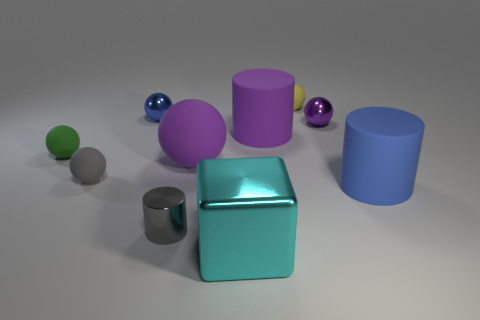There is a big thing that is left of the large cyan thing that is in front of the purple matte object in front of the tiny green thing; what shape is it?
Provide a short and direct response. Sphere. There is a large matte object that is the same color as the big sphere; what is its shape?
Your answer should be very brief. Cylinder. What number of things are either tiny red shiny cylinders or shiny things behind the blue cylinder?
Provide a succinct answer. 2. There is a rubber sphere behind the blue sphere; is its size the same as the cyan metal object?
Make the answer very short. No. What is the material of the sphere that is to the left of the gray ball?
Offer a terse response. Rubber. Are there an equal number of green rubber objects in front of the small gray sphere and big purple cylinders that are right of the cyan shiny block?
Provide a short and direct response. No. What color is the large matte object that is the same shape as the purple metal thing?
Give a very brief answer. Purple. Are there any other things of the same color as the small metal cylinder?
Give a very brief answer. Yes. How many rubber objects are gray objects or large green cubes?
Ensure brevity in your answer.  1. Is the number of tiny rubber spheres to the left of the small blue shiny object greater than the number of large purple blocks?
Offer a terse response. Yes. 